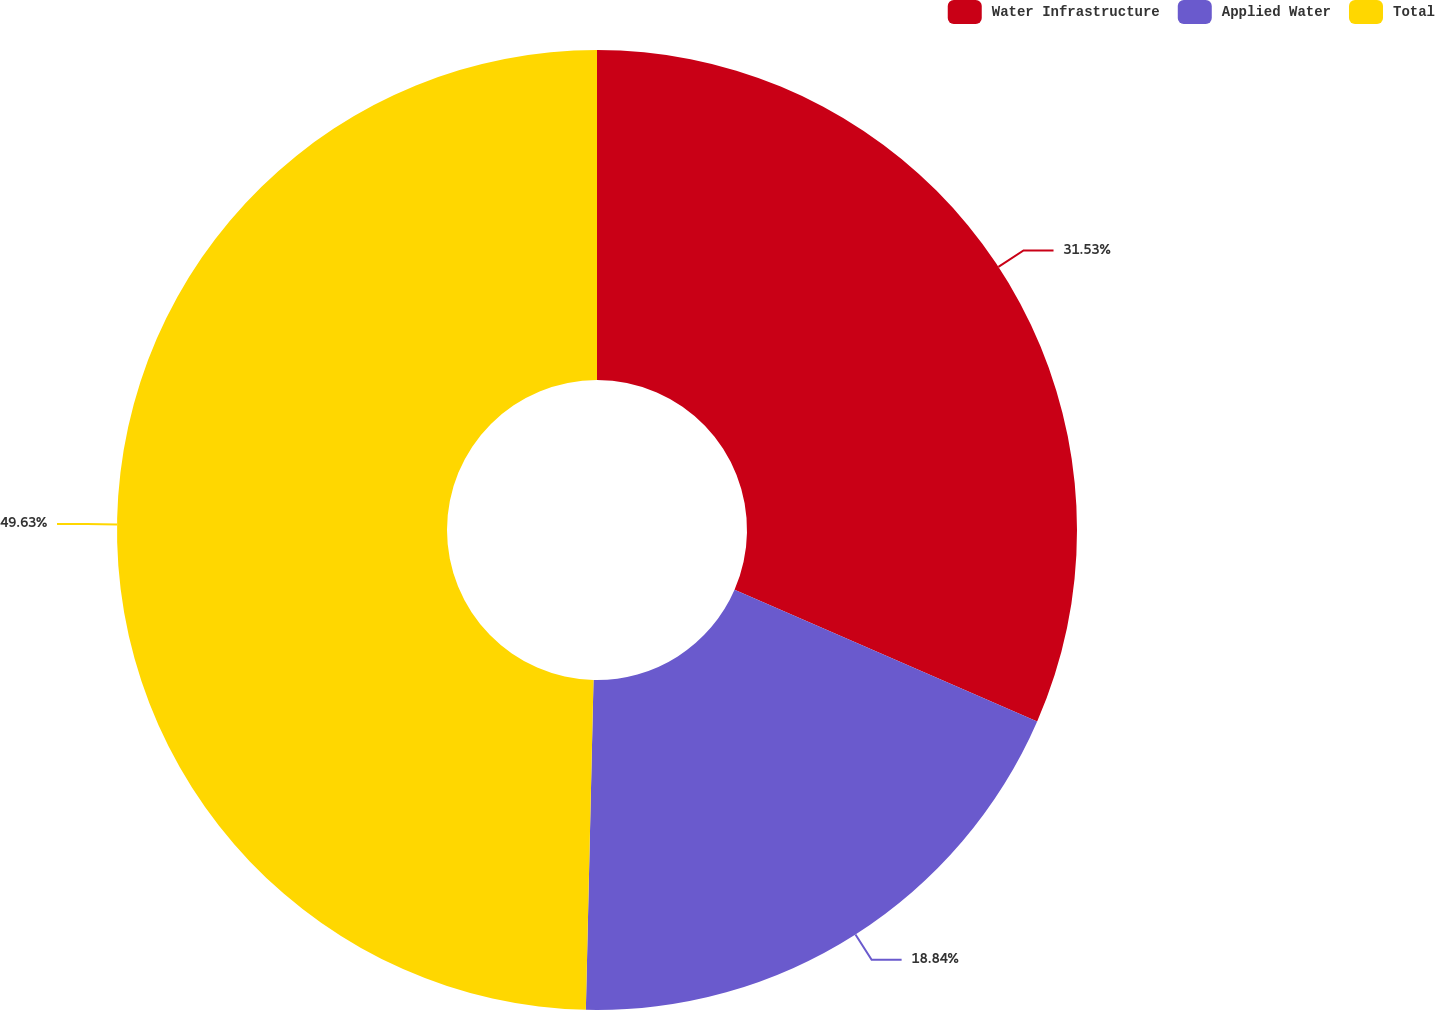Convert chart. <chart><loc_0><loc_0><loc_500><loc_500><pie_chart><fcel>Water Infrastructure<fcel>Applied Water<fcel>Total<nl><fcel>31.53%<fcel>18.84%<fcel>49.63%<nl></chart> 